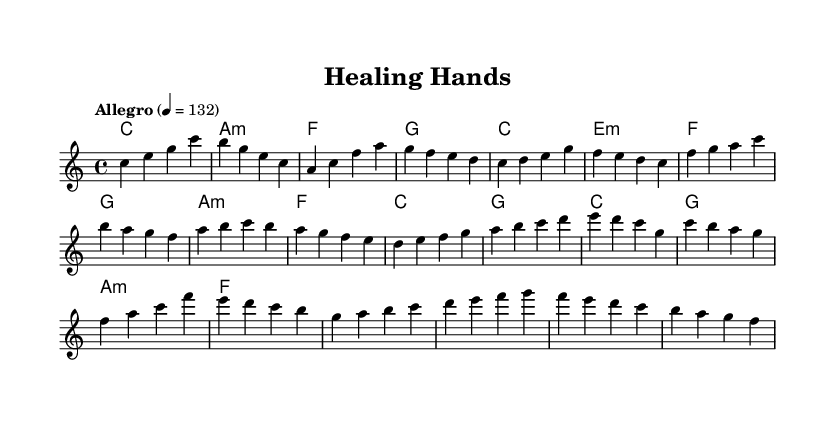What is the key signature of this music? The key signature is C major, which has no sharps or flats.
Answer: C major What is the time signature of this music? The time signature is indicated as 4/4, meaning there are four beats in a measure and the quarter note gets one beat.
Answer: 4/4 What is the tempo marking for this piece? The tempo marking is "Allegro," which indicates a fast-paced performance, with a metronome marking of 132 beats per minute.
Answer: Allegro How many measures are in the melody section? Counting the measures in the melody, there are 16 measures total in the provided section of music.
Answer: 16 What is the first note of the melody? The first note of the melody is C, which is the tonic note and sets the basis for the theme of the piece, aligning with the key signature.
Answer: C What chord follows the first measure? The chord that follows the first measure is A minor (a:m), which provides a contrast to the C major chord and adds emotional depth.
Answer: A minor Which section contains a bridge? The section labeled as "Bridge" in the melody indicates a change in music, characterized by ascending notes that usually lead to a climax; it occurs after the chorus.
Answer: Bridge 